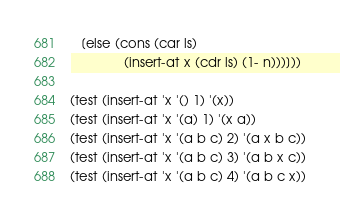Convert code to text. <code><loc_0><loc_0><loc_500><loc_500><_Scheme_>   [else (cons (car ls)
               (insert-at x (cdr ls) (1- n)))]))

(test (insert-at 'x '() 1) '(x))
(test (insert-at 'x '(a) 1) '(x a))
(test (insert-at 'x '(a b c) 2) '(a x b c))
(test (insert-at 'x '(a b c) 3) '(a b x c))
(test (insert-at 'x '(a b c) 4) '(a b c x))
</code> 